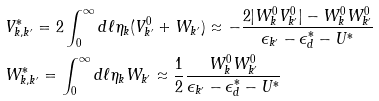<formula> <loc_0><loc_0><loc_500><loc_500>& V _ { k , k ^ { \prime } } ^ { * } = 2 \int _ { 0 } ^ { \infty } d \ell \eta _ { k } ( V _ { k ^ { \prime } } ^ { 0 } + W _ { k ^ { \prime } } ) \approx - \frac { 2 | W _ { k } ^ { 0 } V _ { k ^ { \prime } } ^ { 0 } | - W _ { k } ^ { 0 } W _ { k ^ { \prime } } ^ { 0 } } { \epsilon _ { k ^ { \prime } } - \epsilon _ { d } ^ { * } - U ^ { * } } \\ & W _ { k , k ^ { \prime } } ^ { * } = \int _ { 0 } ^ { \infty } d \ell \eta _ { k } W _ { k ^ { \prime } } \approx \frac { 1 } { 2 } \frac { W _ { k } ^ { 0 } W _ { k ^ { \prime } } ^ { 0 } } { \epsilon _ { k ^ { \prime } } - \epsilon _ { d } ^ { * } - U ^ { * } }</formula> 